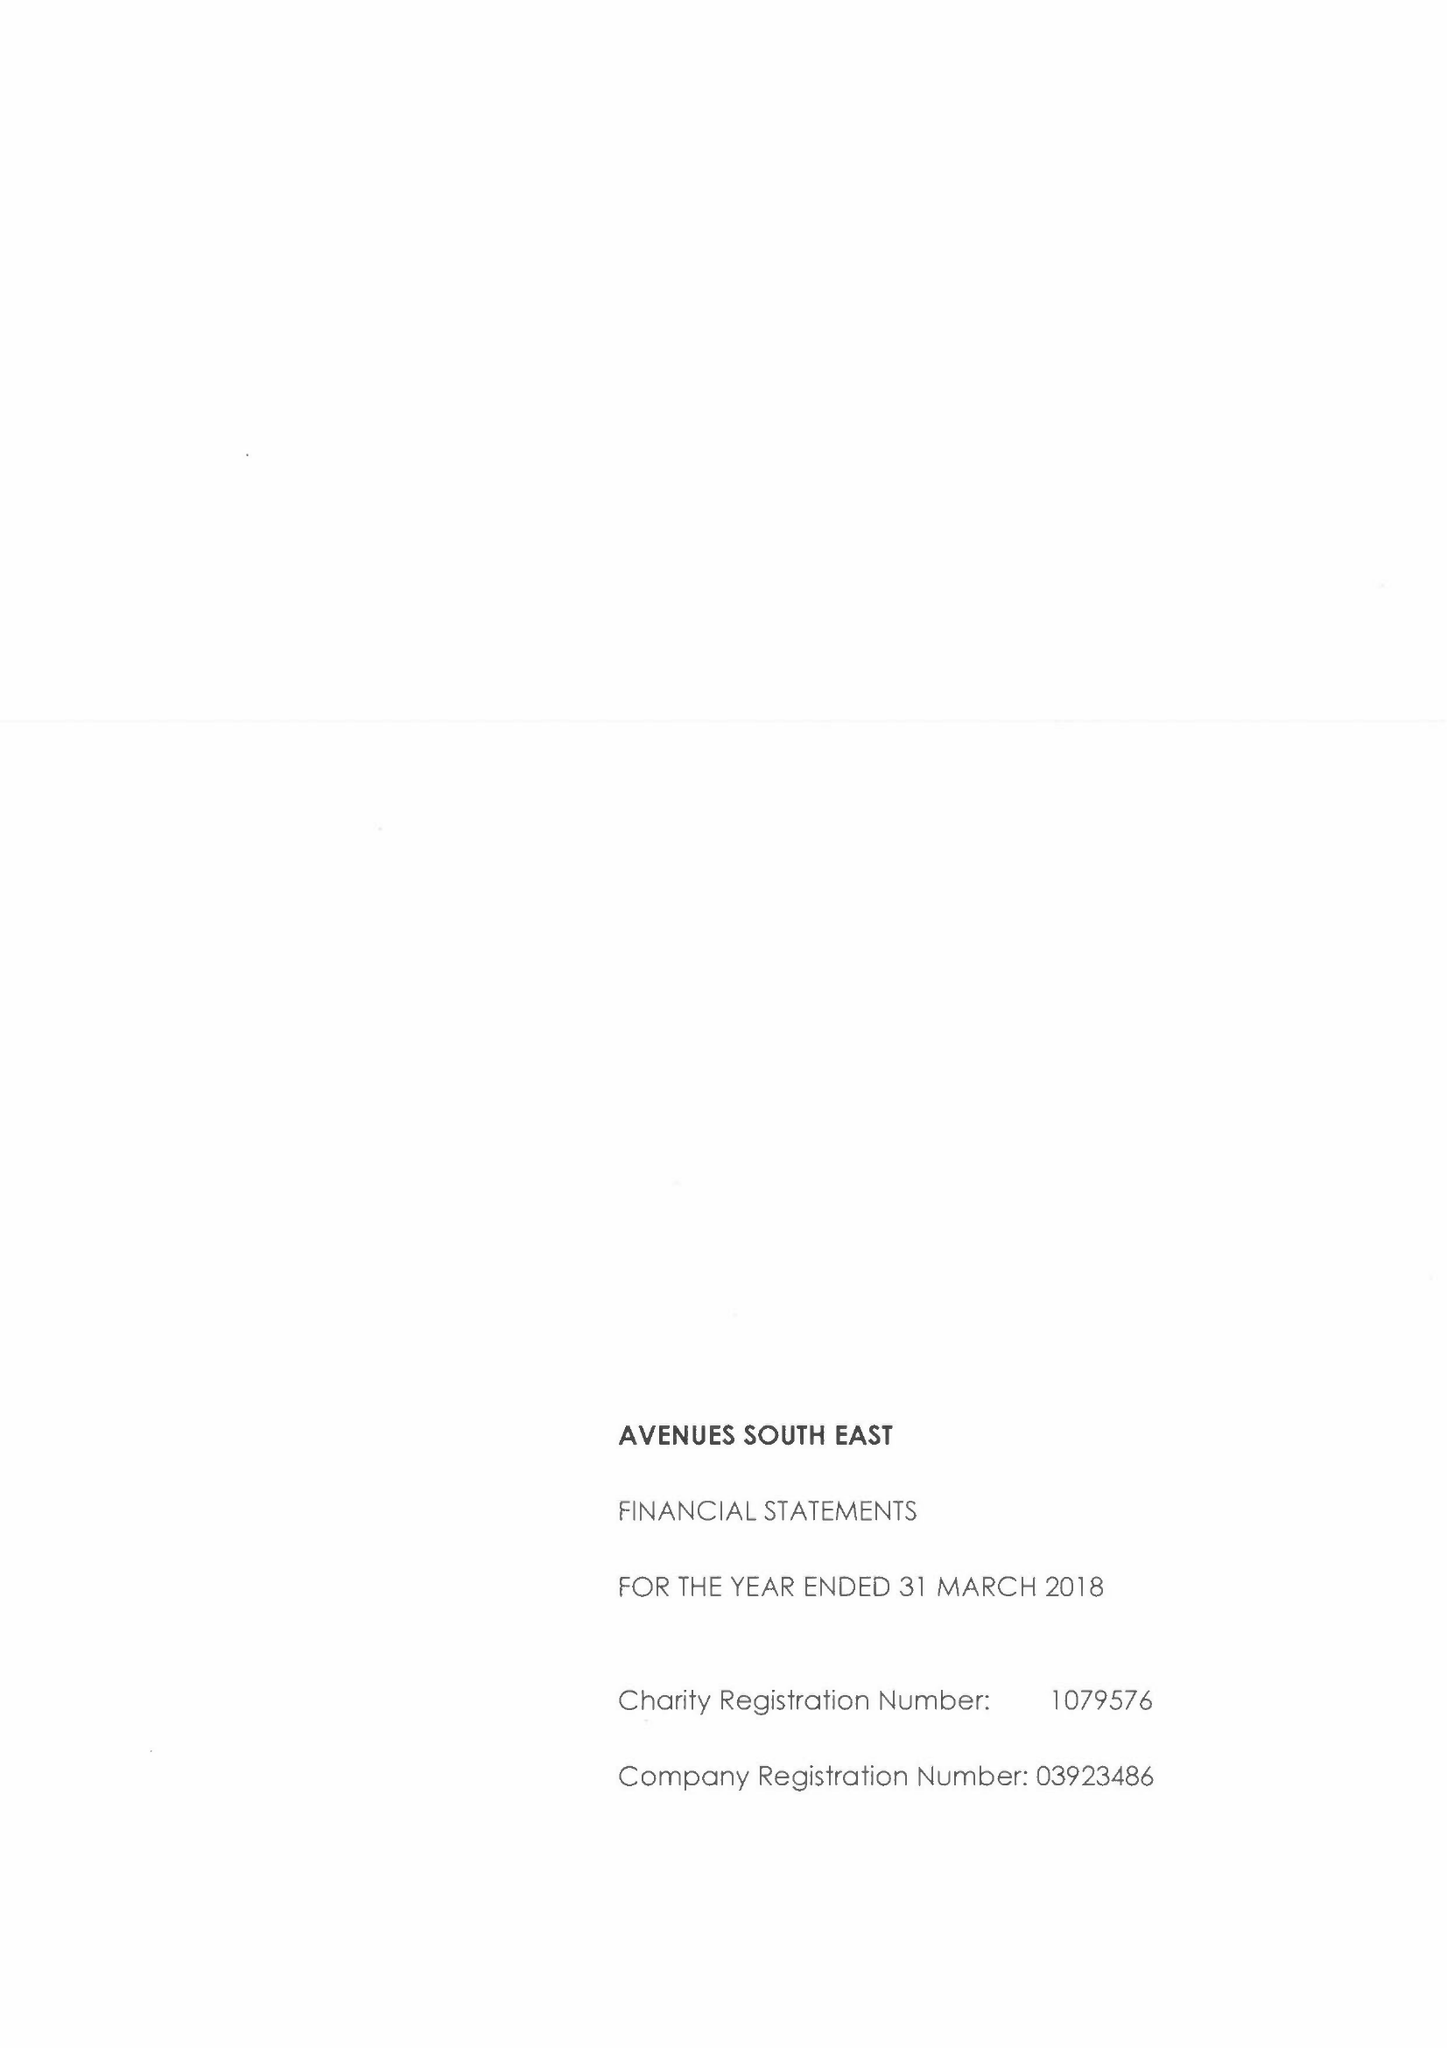What is the value for the address__street_line?
Answer the question using a single word or phrase. 1 MAIDSTONE ROAD 